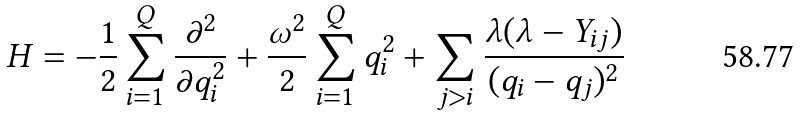Convert formula to latex. <formula><loc_0><loc_0><loc_500><loc_500>H = - \frac { 1 } { 2 } \sum _ { i = 1 } ^ { Q } \frac { \partial ^ { 2 } } { \partial q _ { i } ^ { 2 } } + \frac { \omega ^ { 2 } } { 2 } \sum _ { i = 1 } ^ { Q } q _ { i } ^ { 2 } + \sum _ { j > i } \frac { \lambda ( \lambda - Y _ { i j } ) } { ( q _ { i } - q _ { j } ) ^ { 2 } }</formula> 